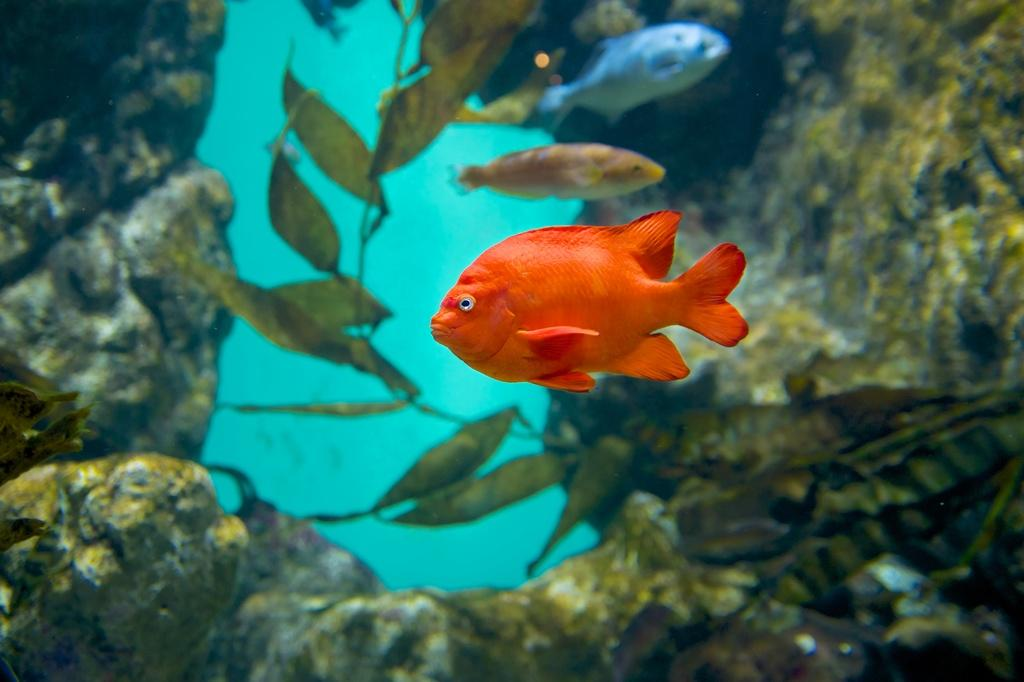How many fishes can be seen in the image? There are three fishes in the image. What is the environment in which the fishes are located? The fishes are in water. What other objects are present in the image besides the fishes? There are stones and a plant in the image. What is the income of the fishes in the image? There is no information about the income of the fishes in the image, as fishes do not have income. 